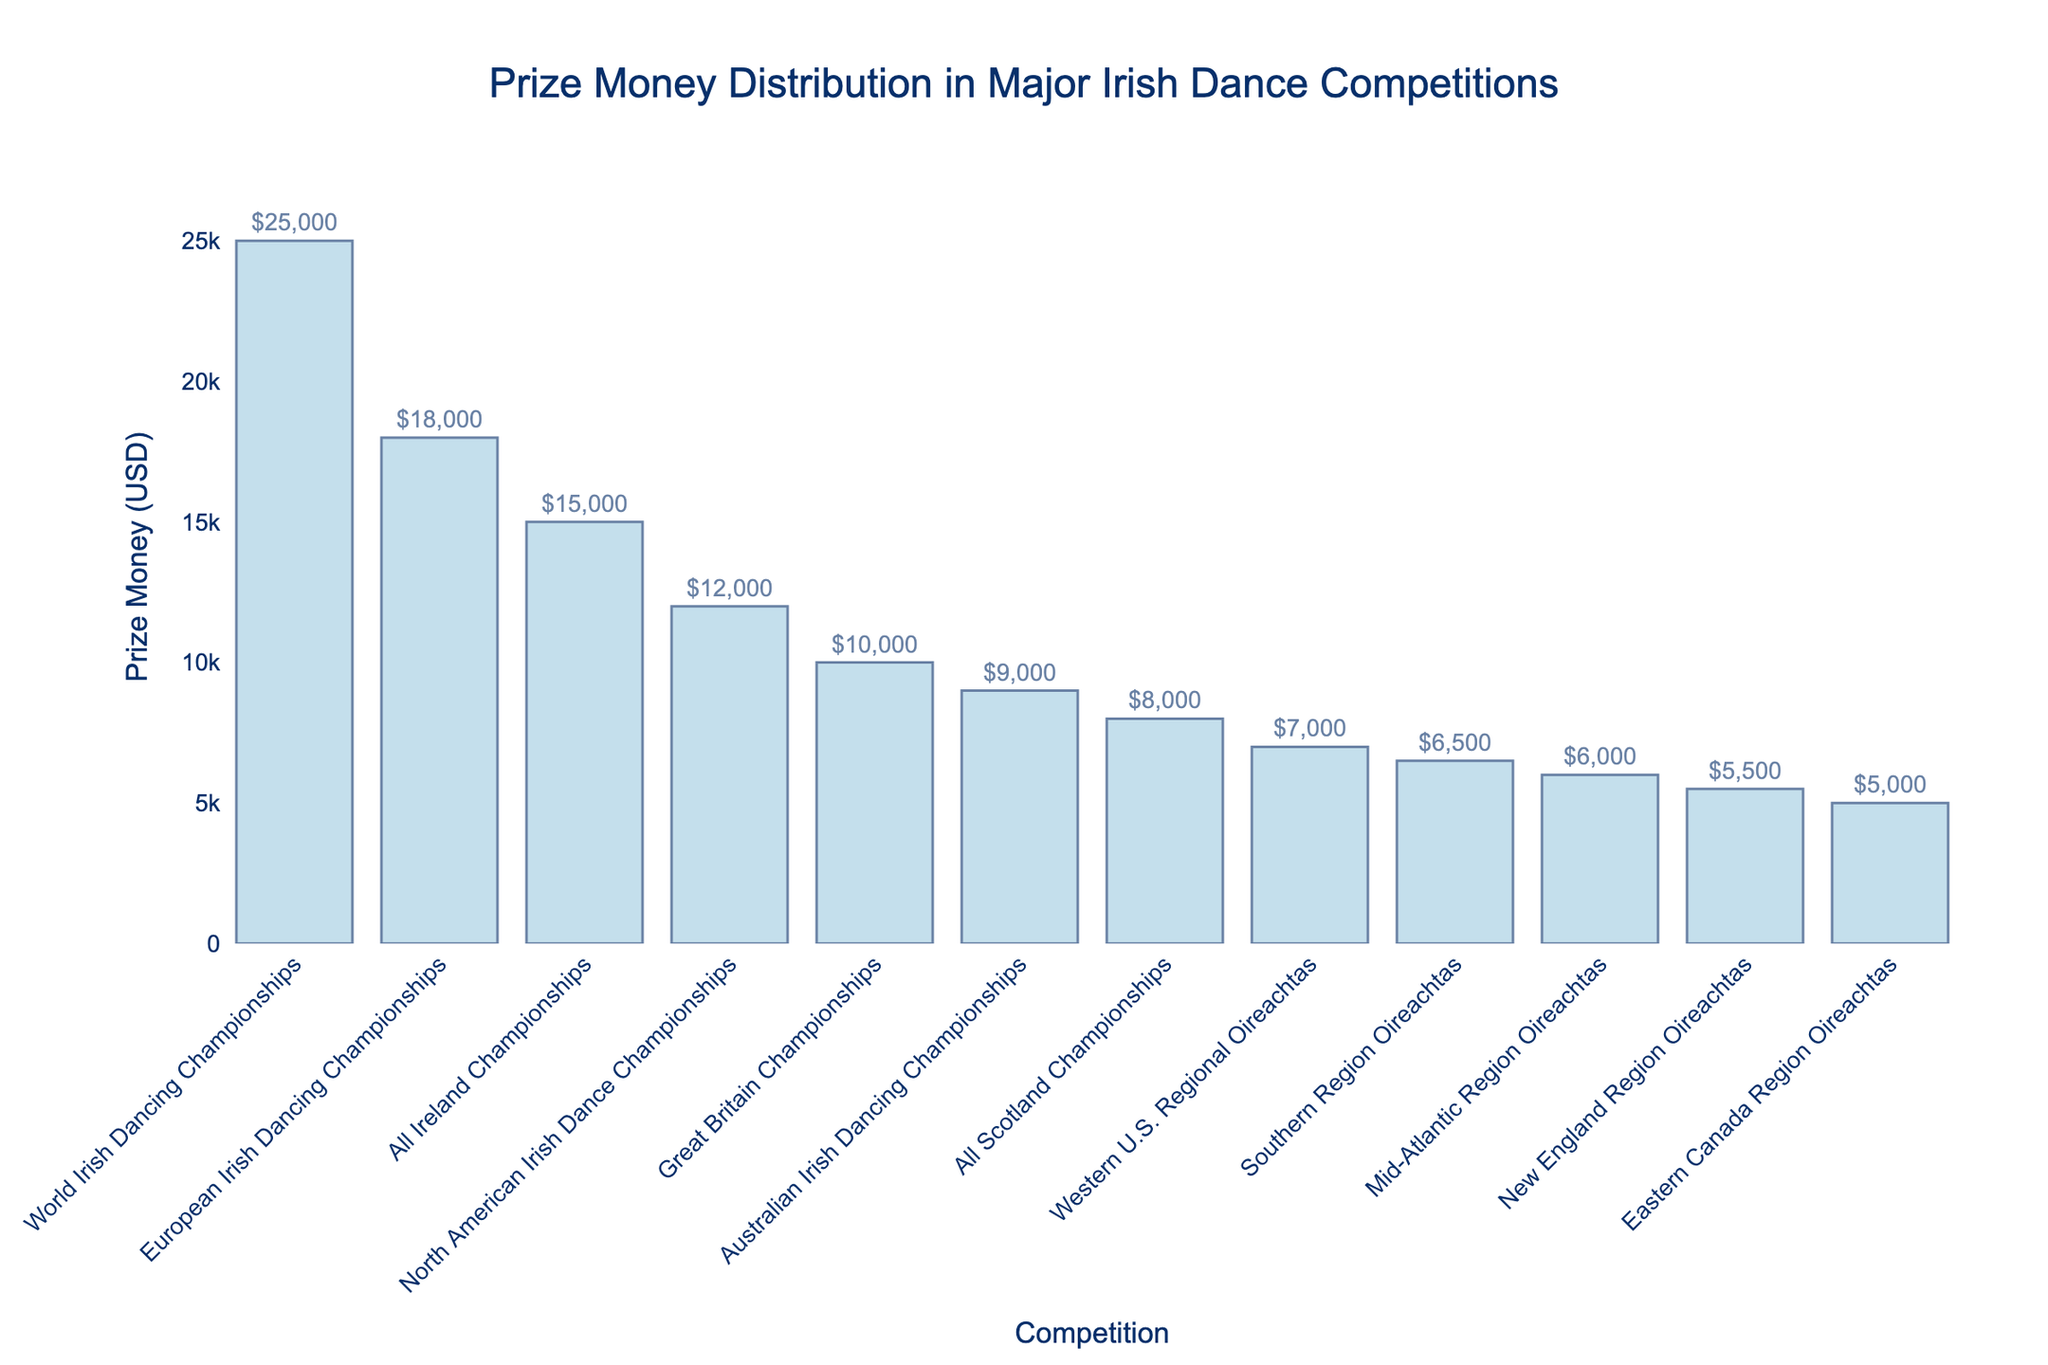What is the highest prize money awarded and in which competition? The highest prize money is identified by looking at the tallest bar in the chart. The competition that offers the highest prize money is the World Irish Dancing Championships with $25,000.
Answer: $25,000, World Irish Dancing Championships Which competition awards the least amount of prize money? The competition with the lowest prize money can be found by looking at the shortest bar in the chart. The Eastern Canada Region Oireachtas offers the least amount of prize money at $5,000.
Answer: Eastern Canada Region Oireachtas, $5,000 How much more is the prize money for the European Irish Dancing Championships compared to the Australian Irish Dancing Championships? To find the difference, locate the bars for both competitions and subtract the prize money of the Australian Irish Dancing Championships ($9,000) from the European Irish Dancing Championships ($18,000). $18,000 - $9,000 = $9,000.
Answer: $9,000 Which regional Oireachtas has the highest prize money and how much is it? To determine the highest prize money among regional Oireachtas, compare the heights of the relevant bars. The Western U.S. Regional Oireachtas has the highest prize money at $7,000.
Answer: Western U.S. Regional Oireachtas, $7,000 Arrange the competitions in descending order of prize money. To list the competitions from highest to lowest prize money, follow the order of the bars from tallest to shortest. World Irish Dancing Championships, European Irish Dancing Championships, All Ireland Championships, North American Irish Dance Championships, Great Britain Championships, Australian Irish Dancing Championships, Western U.S. Regional Oireachtas, Southern Region Oireachtas, Mid-Atlantic Region Oireachtas, New England Region Oireachtas, Eastern Canada Region Oireachtas.
Answer: World Irish Dancing Championships, European Irish Dancing Championships, All Ireland Championships, North American Irish Dance Championships, Great Britain Championships, Australian Irish Dancing Championships, Western U.S. Regional Oireachtas, Southern Region Oireachtas, Mid-Atlantic Region Oireachtas, New England Region Oireachtas, Eastern Canada Region Oireachtas Calculate the average prize money of all listed competitions. Sum the prize money of all competitions and then divide by the number of competitions: (15000 + 25000 + 12000 + 10000 + 8000 + 18000 + 9000 + 7000 + 6500 + 6000 + 5500 + 5000) = 137000. There are 12 competitions, so 137000 ÷ 12 = 11416.67.
Answer: $11,416.67 Is the prize money for the All Ireland Championships greater than the European Irish Dancing Championships? Compare the heights of the bars for these two competitions. The All Ireland Championships has $15,000, while the European Irish Dancing Championships has $18,000. Thus, the All Ireland Championships offers less prize money.
Answer: No What is the total prize money given out by the regional Oireachtas competitions? Add the prize money of all regional Oireachtas competitions: (7000 + 6500 + 6000 + 5500 + 5000) = 30,000.
Answer: $30,000 